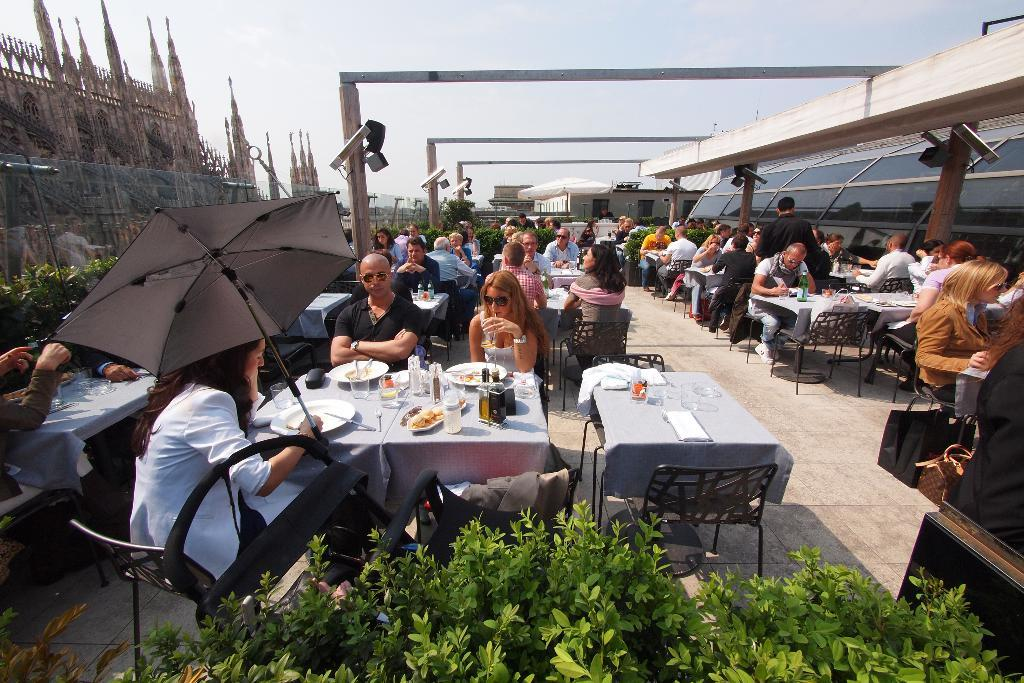What type of establishment is shown in the image? The image depicts a rooftop restaurant. What security measures are in place at the restaurant? There are cameras fixed to poles in the restaurant. Can you describe the woman in the image? There is a woman at a table holding an umbrella. What type of vegetation can be seen in the image? There are plants visible in the image. What can be seen in the background of the image? The sky is visible in the background of the image. What type of balloon is floating above the woman's table in the image? There is no balloon present in the image; the woman is holding an umbrella. What type of popcorn is being served at the restaurant in the image? There is no popcorn present in the image; the image only shows a bowl of ice cream and sweets. 